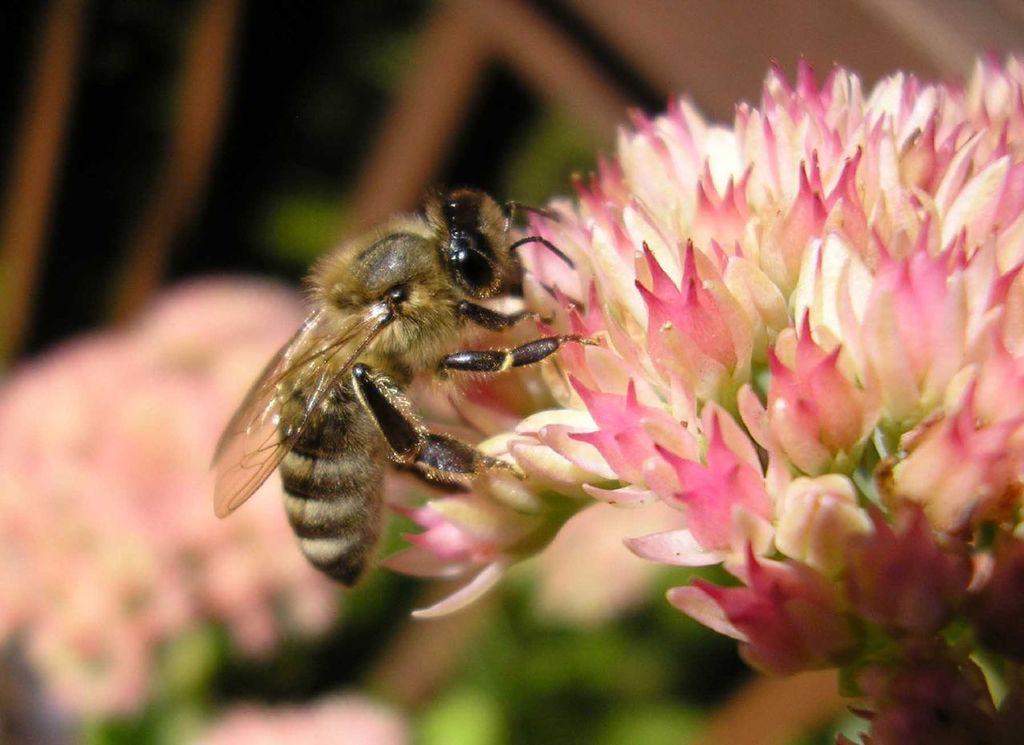Describe this image in one or two sentences. In this image I can see a insect on the flower. Insect is in brown and black color. The flower is in pink and white color. Background is blurred. 